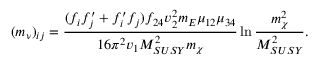<formula> <loc_0><loc_0><loc_500><loc_500>( m _ { \nu } ) _ { i j } = { \frac { ( f _ { i } f _ { j } ^ { \prime } + f _ { i } ^ { \prime } f _ { j } ) f _ { 2 4 } v _ { 2 } ^ { 2 } m _ { E } \mu _ { 1 2 } \mu _ { 3 4 } } { 1 6 \pi ^ { 2 } v _ { 1 } M _ { S U S Y } ^ { 2 } m _ { \chi } } } \ln { \frac { m _ { \chi } ^ { 2 } } { M _ { S U S Y } ^ { 2 } } } .</formula> 